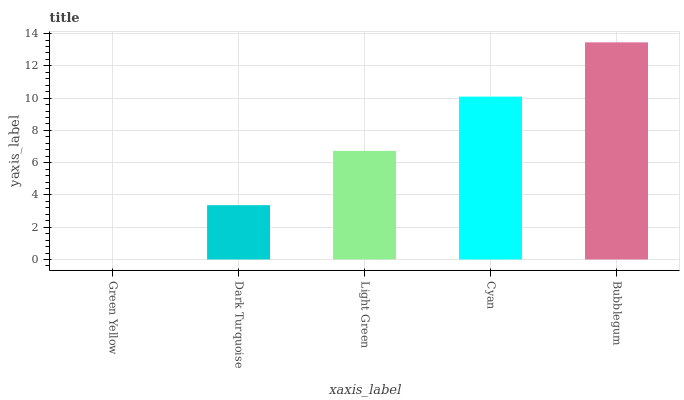Is Green Yellow the minimum?
Answer yes or no. Yes. Is Bubblegum the maximum?
Answer yes or no. Yes. Is Dark Turquoise the minimum?
Answer yes or no. No. Is Dark Turquoise the maximum?
Answer yes or no. No. Is Dark Turquoise greater than Green Yellow?
Answer yes or no. Yes. Is Green Yellow less than Dark Turquoise?
Answer yes or no. Yes. Is Green Yellow greater than Dark Turquoise?
Answer yes or no. No. Is Dark Turquoise less than Green Yellow?
Answer yes or no. No. Is Light Green the high median?
Answer yes or no. Yes. Is Light Green the low median?
Answer yes or no. Yes. Is Green Yellow the high median?
Answer yes or no. No. Is Dark Turquoise the low median?
Answer yes or no. No. 